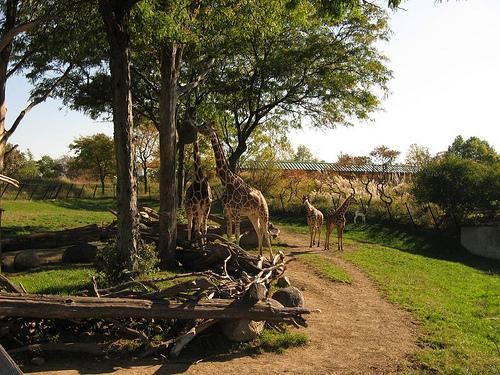Question: why is the car stopped?
Choices:
A. Red light.
B. Drawbridge is up.
C. People are getting out of car.
D. No car.
Answer with the letter. Answer: D Question: how many giraffes are there?
Choices:
A. 4.
B. 5.
C. 6.
D. 7.
Answer with the letter. Answer: A Question: where is the fence?
Choices:
A. On the right.
B. On left.
C. In the background.
D. In the foreground.
Answer with the letter. Answer: B Question: what are they eating?
Choices:
A. Leaves.
B. Grass.
C. Hay.
D. Commercial feed.
Answer with the letter. Answer: A Question: what color is the grass?
Choices:
A. Brown.
B. Tan.
C. Black.
D. Green.
Answer with the letter. Answer: D 